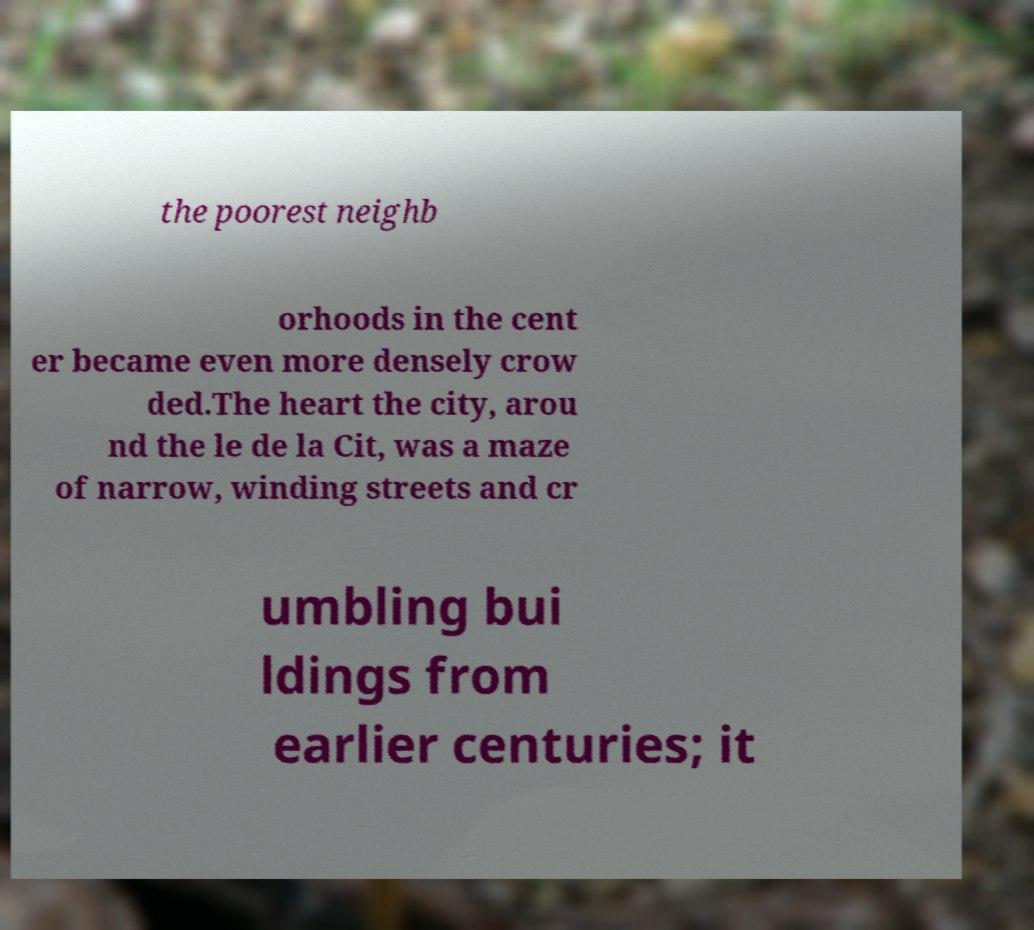I need the written content from this picture converted into text. Can you do that? the poorest neighb orhoods in the cent er became even more densely crow ded.The heart the city, arou nd the le de la Cit, was a maze of narrow, winding streets and cr umbling bui ldings from earlier centuries; it 